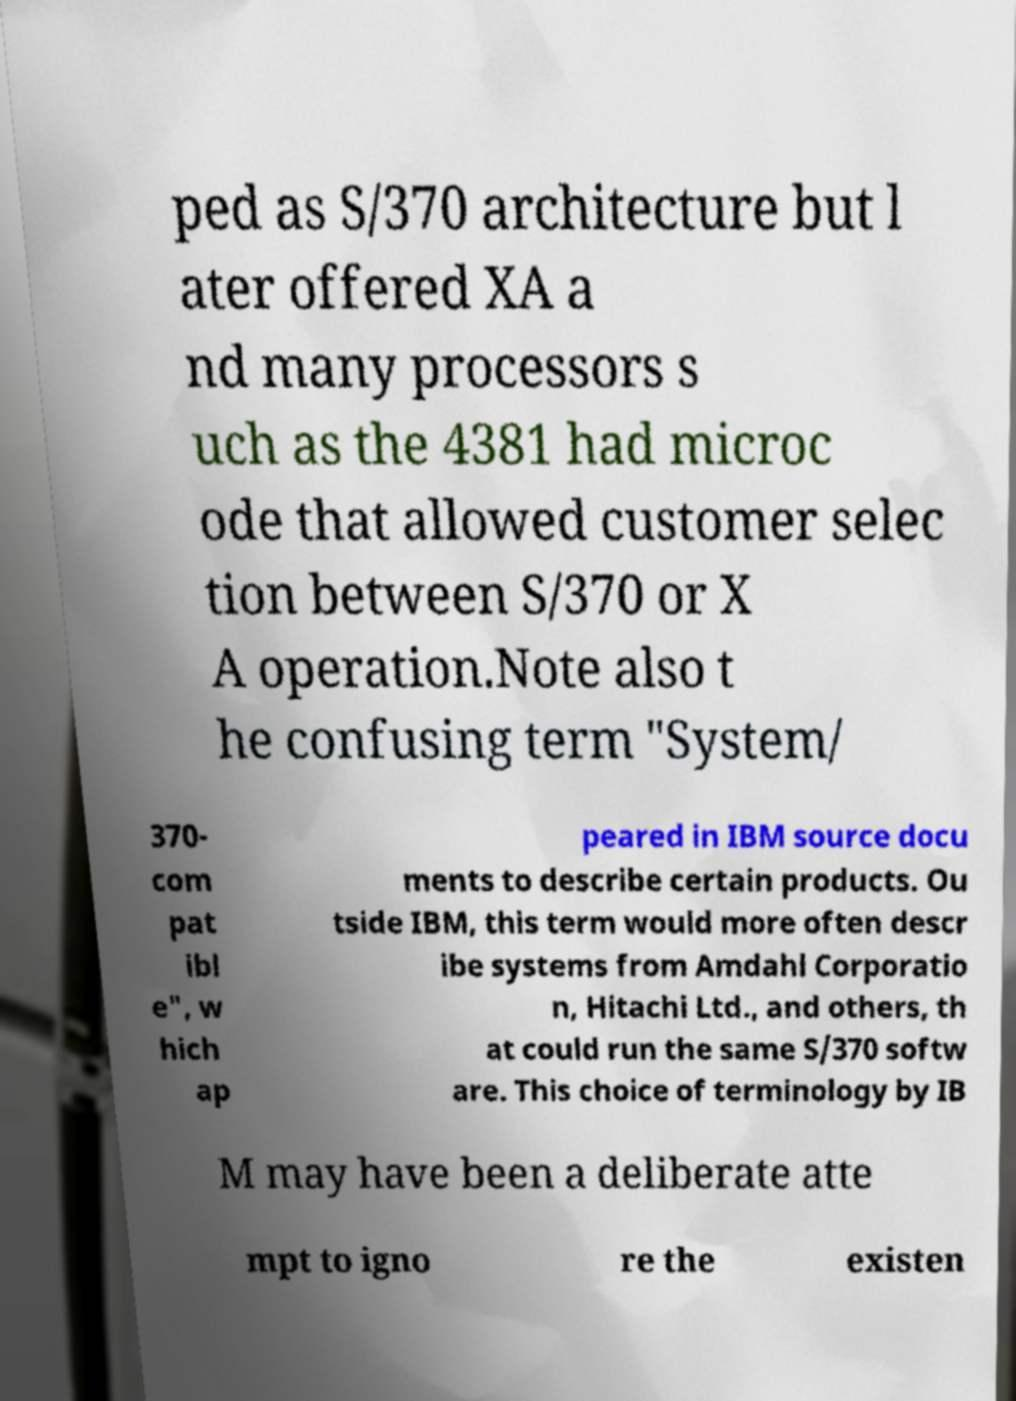For documentation purposes, I need the text within this image transcribed. Could you provide that? ped as S/370 architecture but l ater offered XA a nd many processors s uch as the 4381 had microc ode that allowed customer selec tion between S/370 or X A operation.Note also t he confusing term "System/ 370- com pat ibl e", w hich ap peared in IBM source docu ments to describe certain products. Ou tside IBM, this term would more often descr ibe systems from Amdahl Corporatio n, Hitachi Ltd., and others, th at could run the same S/370 softw are. This choice of terminology by IB M may have been a deliberate atte mpt to igno re the existen 